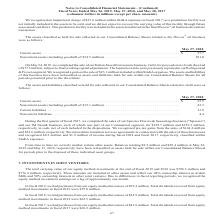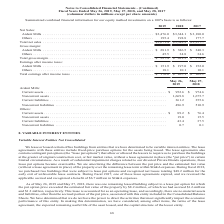According to Conagra Brands's financial document, What was the value of equity that the company purchased during fiscal 2019? According to the financial document, $39.4 million. The relevant text states: "had purchases from our equity method investees of $39.4 million. Total dividends received from equity..." Also, How much dividends that the company received from equity method investments in fiscal 2017, 2018, and 2019, respectively? The document contains multiple relevant values: $68.2 million, $62.5 million, $55.0 million. From the document: "method investments in fiscal 2019 were $55.0 million. method investments in fiscal 2018 were $62.5 million. method investments in fiscal 2017 were $68..." Also, What was the net sales from Ardent Mills in fiscal 2018? According to the financial document, $3,344.1 (in millions). The relevant text states: "Ardent Mills . $3,476.0 $3,344.1 $ 3,180.0..." Also, can you calculate: What is the ratio of dividends that the company received from equity method investments to total earning after income taxes in fiscal 2019? Based on the calculation: 55.0/170.0 , the result is 0.32. This is based on the information: "Total earnings after income taxes . $ 170.0 $ 207.1 $ 162.1 method investments in fiscal 2019 were $55.0 million...." The key data points involved are: 170.0, 55.0. Also, can you calculate: What is the average of Ardent Mills’ net sales from 2017 to 2019?  To answer this question, I need to perform calculations using the financial data. The calculation is: (3,476.0+3,344.1+3,180.0)/3 , which equals 3333.37 (in millions). This is based on the information: "Ardent Mills . $3,476.0 $3,344.1 $ 3,180.0 Ardent Mills . $3,476.0 $3,344.1 $ 3,180.0 Ardent Mills . $3,476.0 $3,344.1 $ 3,180.0..." The key data points involved are: 3,180.0, 3,344.1, 3,476.0. Also, can you calculate: What is Ardent Mills’ gross profit margin ratio for the fiscal year 2017? Based on the calculation: 340.3/3,180.0 , the result is 0.11. This is based on the information: "Ardent Mills . $ 281.9 $ 386.5 $ 340.3 Ardent Mills . $3,476.0 $3,344.1 $ 3,180.0..." The key data points involved are: 3,180.0, 340.3. 